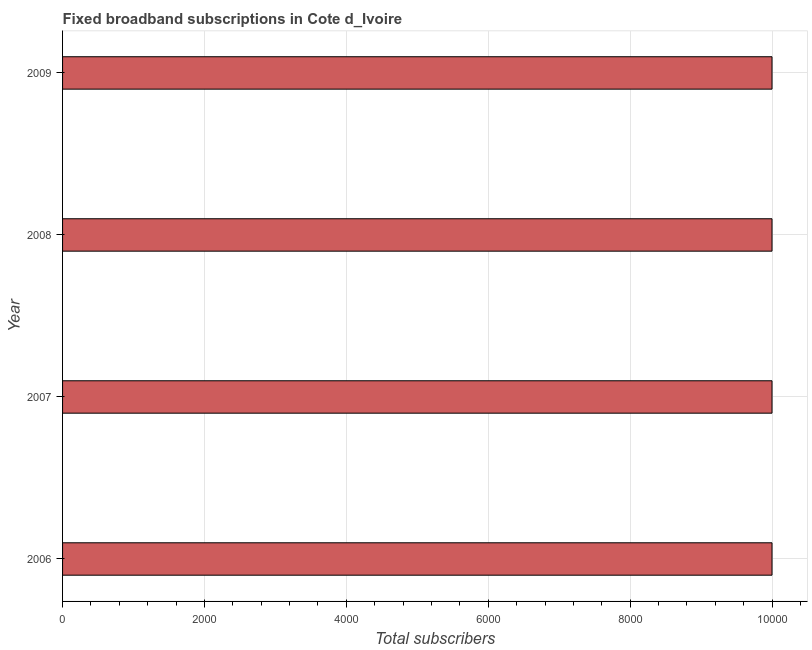Does the graph contain any zero values?
Your answer should be very brief. No. What is the title of the graph?
Offer a very short reply. Fixed broadband subscriptions in Cote d_Ivoire. What is the label or title of the X-axis?
Give a very brief answer. Total subscribers. What is the label or title of the Y-axis?
Give a very brief answer. Year. What is the total number of fixed broadband subscriptions in 2008?
Make the answer very short. 10000. Across all years, what is the maximum total number of fixed broadband subscriptions?
Keep it short and to the point. 10000. In which year was the total number of fixed broadband subscriptions maximum?
Keep it short and to the point. 2006. Is the total number of fixed broadband subscriptions in 2008 less than that in 2009?
Give a very brief answer. No. Is the difference between the total number of fixed broadband subscriptions in 2007 and 2009 greater than the difference between any two years?
Give a very brief answer. Yes. What is the difference between the highest and the second highest total number of fixed broadband subscriptions?
Your answer should be very brief. 0. Is the sum of the total number of fixed broadband subscriptions in 2007 and 2009 greater than the maximum total number of fixed broadband subscriptions across all years?
Make the answer very short. Yes. What is the difference between the highest and the lowest total number of fixed broadband subscriptions?
Your answer should be compact. 0. How many bars are there?
Keep it short and to the point. 4. How many years are there in the graph?
Provide a short and direct response. 4. What is the difference between two consecutive major ticks on the X-axis?
Your answer should be compact. 2000. Are the values on the major ticks of X-axis written in scientific E-notation?
Provide a short and direct response. No. What is the Total subscribers in 2007?
Your answer should be very brief. 10000. What is the Total subscribers of 2008?
Make the answer very short. 10000. What is the difference between the Total subscribers in 2006 and 2008?
Offer a terse response. 0. What is the difference between the Total subscribers in 2007 and 2008?
Make the answer very short. 0. What is the ratio of the Total subscribers in 2006 to that in 2007?
Provide a short and direct response. 1. What is the ratio of the Total subscribers in 2006 to that in 2009?
Offer a terse response. 1. What is the ratio of the Total subscribers in 2007 to that in 2008?
Ensure brevity in your answer.  1. What is the ratio of the Total subscribers in 2008 to that in 2009?
Your answer should be very brief. 1. 